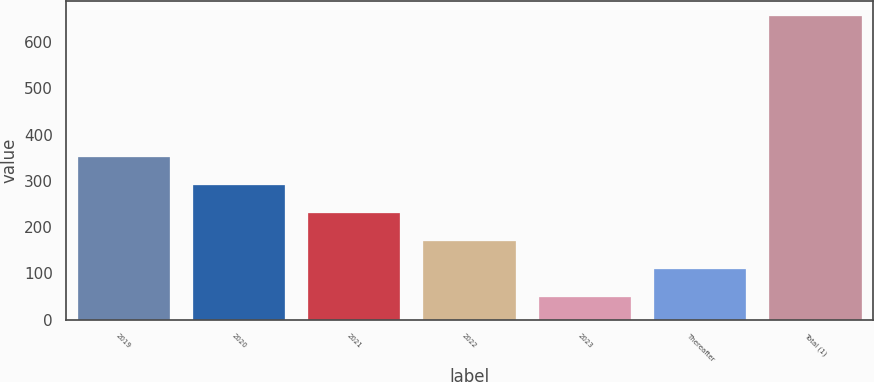Convert chart. <chart><loc_0><loc_0><loc_500><loc_500><bar_chart><fcel>2019<fcel>2020<fcel>2021<fcel>2022<fcel>2023<fcel>Thereafter<fcel>Total (1)<nl><fcel>352.5<fcel>291.6<fcel>230.7<fcel>169.8<fcel>48<fcel>108.9<fcel>657<nl></chart> 